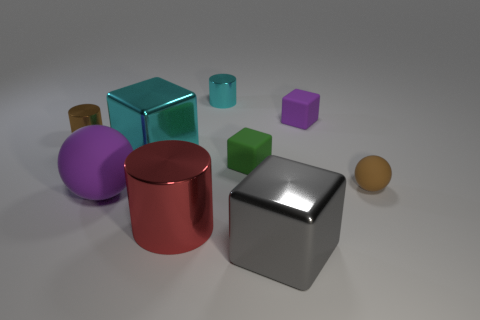Can you describe the texture of the objects? The objects in the image all have a smooth, reflective surface, suggesting a metallic or polished finish that catches the light, enhancing their three-dimensional quality. 